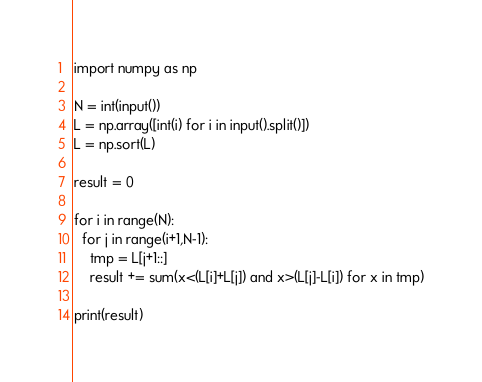<code> <loc_0><loc_0><loc_500><loc_500><_Python_>import numpy as np

N = int(input())
L = np.array([int(i) for i in input().split()])
L = np.sort(L)

result = 0

for i in range(N):
  for j in range(i+1,N-1):
    tmp = L[j+1::]
    result += sum(x<(L[i]+L[j]) and x>(L[j]-L[i]) for x in tmp)

print(result)</code> 